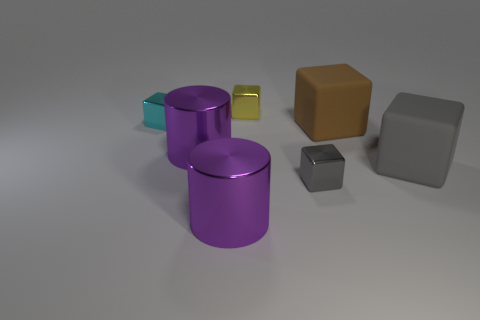What is the material of the gray object that is to the right of the large matte thing that is to the left of the large cube that is right of the brown rubber block?
Your answer should be compact. Rubber. How many other objects are the same material as the small cyan thing?
Offer a terse response. 4. There is a small block to the right of the small yellow thing; how many large gray objects are in front of it?
Your answer should be very brief. 0. How many balls are brown matte things or cyan metal things?
Your response must be concise. 0. The cube that is in front of the yellow object and behind the big brown rubber thing is what color?
Make the answer very short. Cyan. There is a cylinder that is in front of the big rubber thing in front of the brown rubber block; what is its color?
Ensure brevity in your answer.  Purple. Do the brown block and the cyan block have the same size?
Keep it short and to the point. No. Is the material of the cyan thing behind the small gray object the same as the small cube in front of the cyan object?
Provide a short and direct response. Yes. The big purple shiny thing left of the large cylinder that is in front of the small shiny thing that is in front of the tiny cyan object is what shape?
Your answer should be very brief. Cylinder. Are there more yellow metal cylinders than big gray things?
Provide a succinct answer. No. 